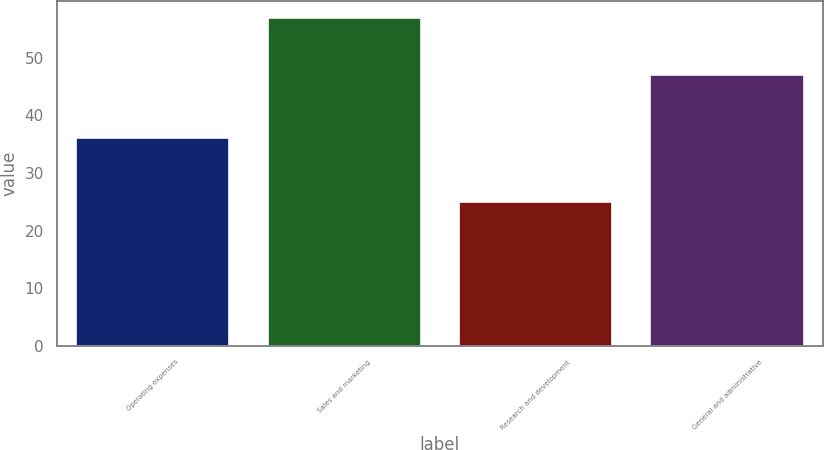Convert chart. <chart><loc_0><loc_0><loc_500><loc_500><bar_chart><fcel>Operating expenses<fcel>Sales and marketing<fcel>Research and development<fcel>General and administrative<nl><fcel>36<fcel>57<fcel>25<fcel>47<nl></chart> 